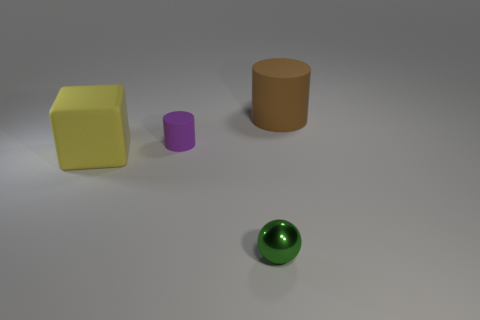Add 2 purple matte cylinders. How many objects exist? 6 Subtract all cubes. How many objects are left? 3 Subtract 0 green blocks. How many objects are left? 4 Subtract all gray matte cylinders. Subtract all matte blocks. How many objects are left? 3 Add 1 large blocks. How many large blocks are left? 2 Add 1 purple things. How many purple things exist? 2 